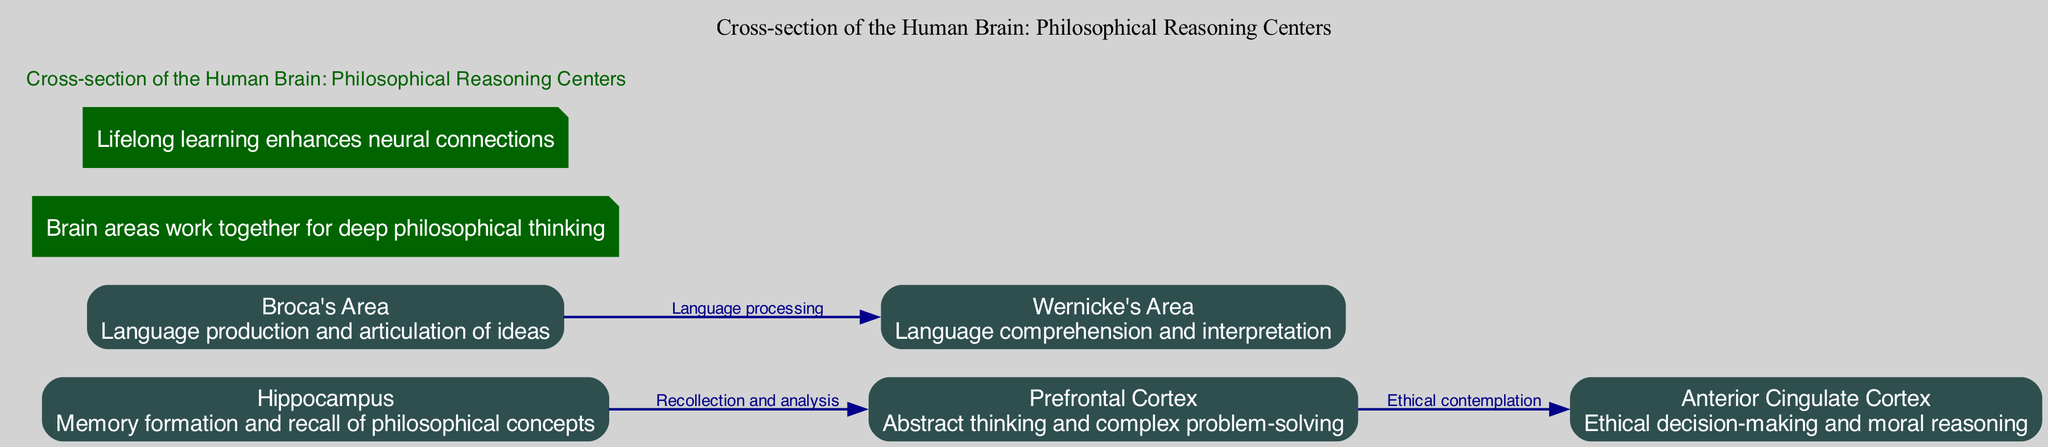What is the main function of the Prefrontal Cortex? The diagram indicates that the Prefrontal Cortex is associated with "Abstract thinking and complex problem-solving." This description directly correlates to the node representing the Prefrontal Cortex.
Answer: Abstract thinking and complex problem-solving How many main elements are highlighted in the diagram? By counting the nodes listed under the main elements, there are five unique areas highlighted: Prefrontal Cortex, Broca's Area, Wernicke's Area, Hippocampus, and Anterior Cingulate Cortex.
Answer: 5 What relationship is depicted between the Prefrontal Cortex and the Anterior Cingulate Cortex? The diagram specifies the connection from the Prefrontal Cortex to the Anterior Cingulate Cortex with the label "Ethical contemplation." This indicates a flow of thought between these two regions regarding ethical considerations.
Answer: Ethical contemplation Which area is responsible for memory formation and recall of philosophical concepts? According to the diagram, the Hippocampus is identified as responsible for this function. Its role is linked specifically to the memory aspects related to philosophical thinking.
Answer: Hippocampus What is the role of Broca's Area in philosophical thinking? Broca's Area is labeled with "Language production and articulation of ideas." This shows its significance in the verbal expression of philosophical thoughts, facilitating communication of complex ideas.
Answer: Language production and articulation of ideas Which two areas are connected by the label “Language processing”? The diagram explicitly states that Broca's Area and Wernicke's Area are connected with the label "Language processing," signifying their collaborative role in handling language-related tasks.
Answer: Broca's Area and Wernicke's Area How does the Hippocampus contribute to the Prefrontal Cortex based on the diagram? The diagram notes a connection from the Hippocampus to the Prefrontal Cortex labeled as "Recollection and analysis." This implies that memories retrieved from the Hippocampus are analyzed within the Prefrontal Cortex, enhancing philosophical reasoning.
Answer: Recollection and analysis What does the diagram suggest about lifelong learning? The additional notes state "Lifelong learning enhances neural connections." This suggests that continuous intellectual engagement is beneficial for maintaining and improving the brain's functional connections, especially in the context of philosophical reasoning.
Answer: Enhances neural connections 